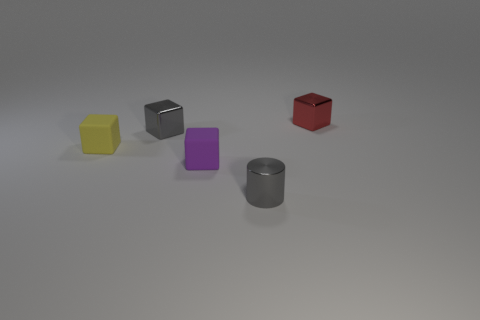Do the metal cylinder and the metallic object left of the cylinder have the same color?
Make the answer very short. Yes. What is the material of the purple cube on the left side of the tiny gray metal cylinder?
Give a very brief answer. Rubber. Are there any small objects of the same color as the metallic cylinder?
Give a very brief answer. Yes. The shiny cylinder that is the same size as the purple block is what color?
Your answer should be compact. Gray. What number of large things are yellow matte blocks or red cylinders?
Keep it short and to the point. 0. Are there an equal number of red metal blocks left of the red thing and small blocks that are behind the small yellow thing?
Your response must be concise. No. How many brown spheres have the same size as the gray shiny block?
Keep it short and to the point. 0. What number of red objects are cylinders or shiny cubes?
Make the answer very short. 1. Is the number of gray blocks in front of the yellow matte object the same as the number of yellow matte spheres?
Your answer should be compact. Yes. How many other tiny things have the same shape as the small purple matte thing?
Offer a very short reply. 3. 